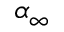Convert formula to latex. <formula><loc_0><loc_0><loc_500><loc_500>\alpha _ { \infty }</formula> 